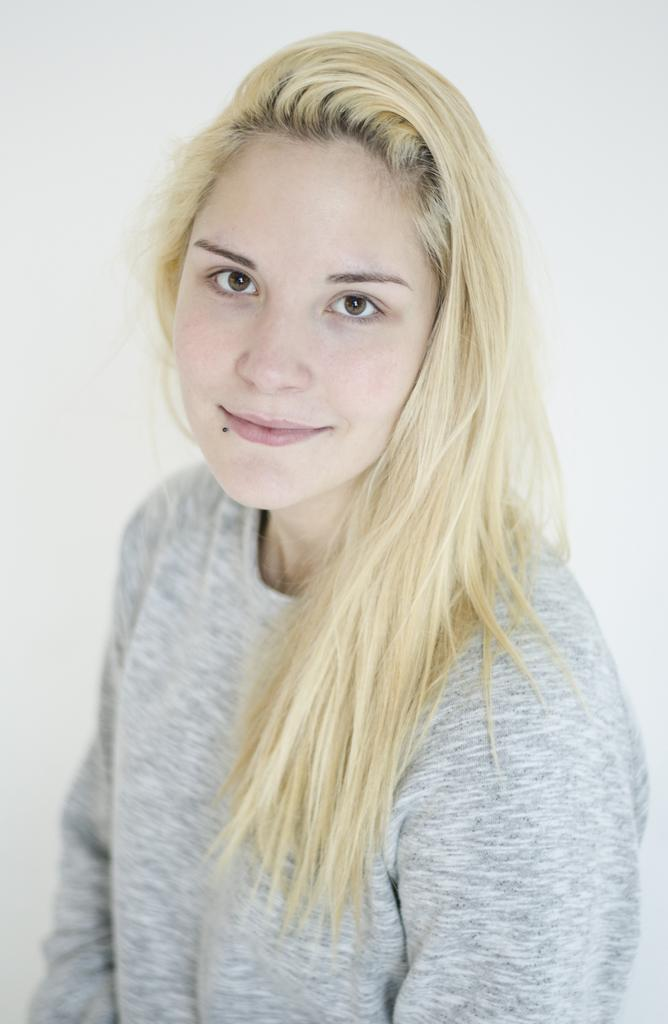Who is the main subject in the image? There is a woman in the image. What is the woman wearing? The woman is wearing a grey top. What color is the background of the image? The background of the image is white. What type of fruit can be seen in the woman's hand in the image? There is no fruit present in the image; the woman is not holding any fruit. 